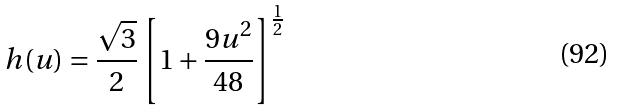Convert formula to latex. <formula><loc_0><loc_0><loc_500><loc_500>h ( u ) = \frac { \sqrt { 3 } } { 2 } \left [ 1 + \frac { 9 u ^ { 2 } } { 4 8 } \right ] ^ { \frac { 1 } { 2 } }</formula> 